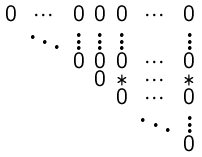Convert formula to latex. <formula><loc_0><loc_0><loc_500><loc_500>\begin{smallmatrix} 0 & \cdots & 0 & 0 & 0 & \cdots & 0 \\ & \ddots & \vdots & \vdots & \vdots & & \vdots \\ & & 0 & 0 & 0 & \cdots & 0 \\ & & & 0 & * & \cdots & * \\ & & & & 0 & \cdots & 0 \\ & & & & & \ddots & \vdots \\ & & & & & & 0 \end{smallmatrix}</formula> 